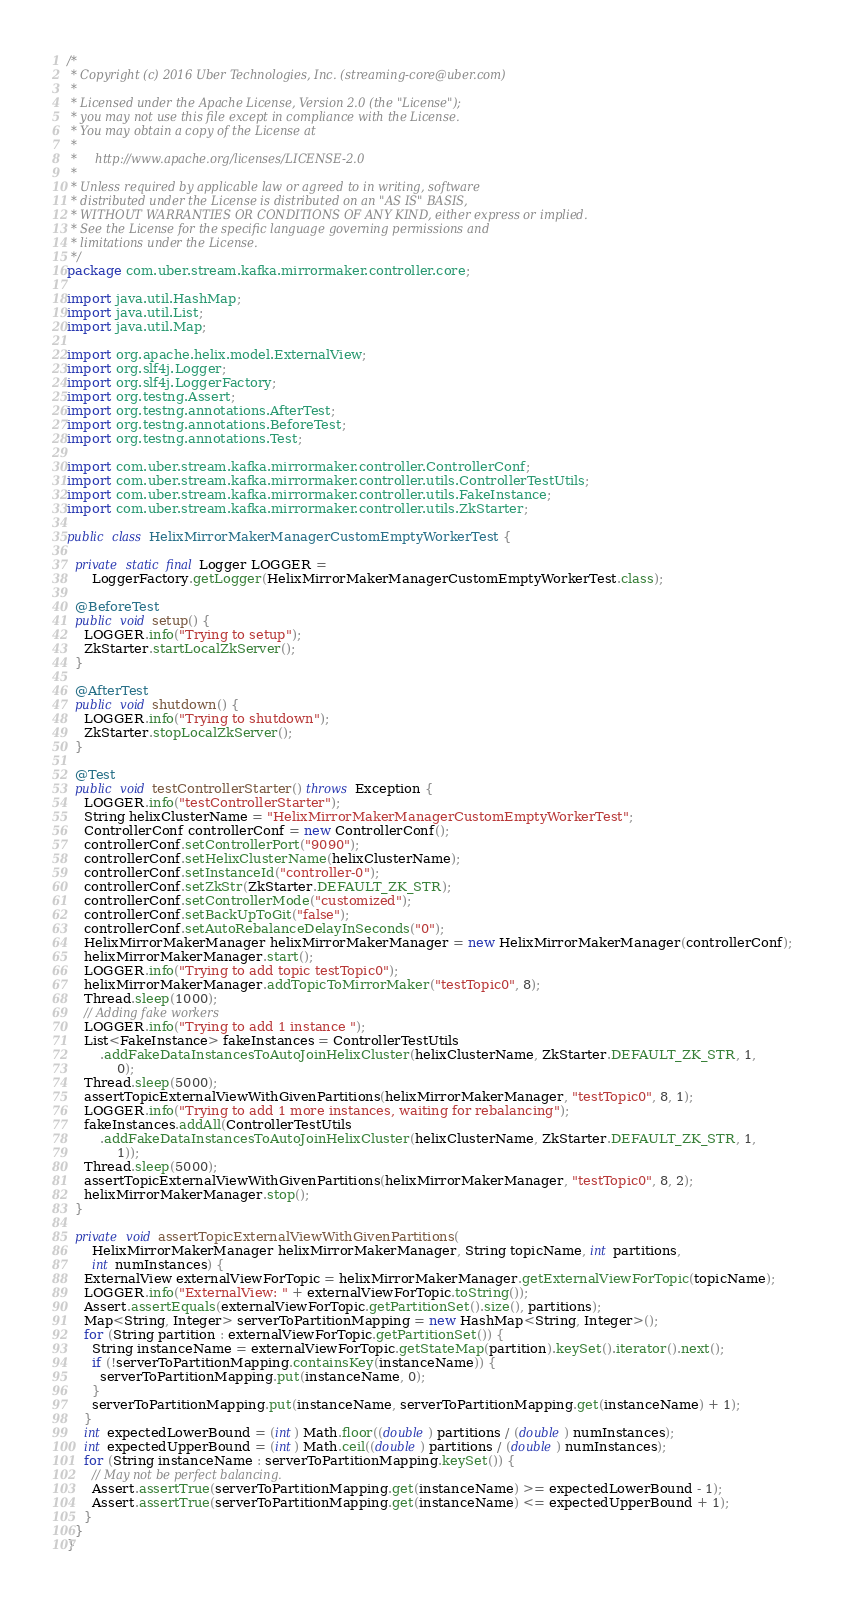Convert code to text. <code><loc_0><loc_0><loc_500><loc_500><_Java_>/*
 * Copyright (c) 2016 Uber Technologies, Inc. (streaming-core@uber.com)
 *
 * Licensed under the Apache License, Version 2.0 (the "License");
 * you may not use this file except in compliance with the License.
 * You may obtain a copy of the License at
 *
 *     http://www.apache.org/licenses/LICENSE-2.0
 *
 * Unless required by applicable law or agreed to in writing, software
 * distributed under the License is distributed on an "AS IS" BASIS,
 * WITHOUT WARRANTIES OR CONDITIONS OF ANY KIND, either express or implied.
 * See the License for the specific language governing permissions and
 * limitations under the License.
 */
package com.uber.stream.kafka.mirrormaker.controller.core;

import java.util.HashMap;
import java.util.List;
import java.util.Map;

import org.apache.helix.model.ExternalView;
import org.slf4j.Logger;
import org.slf4j.LoggerFactory;
import org.testng.Assert;
import org.testng.annotations.AfterTest;
import org.testng.annotations.BeforeTest;
import org.testng.annotations.Test;

import com.uber.stream.kafka.mirrormaker.controller.ControllerConf;
import com.uber.stream.kafka.mirrormaker.controller.utils.ControllerTestUtils;
import com.uber.stream.kafka.mirrormaker.controller.utils.FakeInstance;
import com.uber.stream.kafka.mirrormaker.controller.utils.ZkStarter;

public class HelixMirrorMakerManagerCustomEmptyWorkerTest {

  private static final Logger LOGGER =
      LoggerFactory.getLogger(HelixMirrorMakerManagerCustomEmptyWorkerTest.class);

  @BeforeTest
  public void setup() {
    LOGGER.info("Trying to setup");
    ZkStarter.startLocalZkServer();
  }

  @AfterTest
  public void shutdown() {
    LOGGER.info("Trying to shutdown");
    ZkStarter.stopLocalZkServer();
  }

  @Test
  public void testControllerStarter() throws Exception {
    LOGGER.info("testControllerStarter");
    String helixClusterName = "HelixMirrorMakerManagerCustomEmptyWorkerTest";
    ControllerConf controllerConf = new ControllerConf();
    controllerConf.setControllerPort("9090");
    controllerConf.setHelixClusterName(helixClusterName);
    controllerConf.setInstanceId("controller-0");
    controllerConf.setZkStr(ZkStarter.DEFAULT_ZK_STR);
    controllerConf.setControllerMode("customized");
    controllerConf.setBackUpToGit("false");
    controllerConf.setAutoRebalanceDelayInSeconds("0");
    HelixMirrorMakerManager helixMirrorMakerManager = new HelixMirrorMakerManager(controllerConf);
    helixMirrorMakerManager.start();
    LOGGER.info("Trying to add topic testTopic0");
    helixMirrorMakerManager.addTopicToMirrorMaker("testTopic0", 8);
    Thread.sleep(1000);
    // Adding fake workers
    LOGGER.info("Trying to add 1 instance ");
    List<FakeInstance> fakeInstances = ControllerTestUtils
        .addFakeDataInstancesToAutoJoinHelixCluster(helixClusterName, ZkStarter.DEFAULT_ZK_STR, 1,
            0);
    Thread.sleep(5000);
    assertTopicExternalViewWithGivenPartitions(helixMirrorMakerManager, "testTopic0", 8, 1);
    LOGGER.info("Trying to add 1 more instances, waiting for rebalancing");
    fakeInstances.addAll(ControllerTestUtils
        .addFakeDataInstancesToAutoJoinHelixCluster(helixClusterName, ZkStarter.DEFAULT_ZK_STR, 1,
            1));
    Thread.sleep(5000);
    assertTopicExternalViewWithGivenPartitions(helixMirrorMakerManager, "testTopic0", 8, 2);
    helixMirrorMakerManager.stop();
  }

  private void assertTopicExternalViewWithGivenPartitions(
      HelixMirrorMakerManager helixMirrorMakerManager, String topicName, int partitions,
      int numInstances) {
    ExternalView externalViewForTopic = helixMirrorMakerManager.getExternalViewForTopic(topicName);
    LOGGER.info("ExternalView: " + externalViewForTopic.toString());
    Assert.assertEquals(externalViewForTopic.getPartitionSet().size(), partitions);
    Map<String, Integer> serverToPartitionMapping = new HashMap<String, Integer>();
    for (String partition : externalViewForTopic.getPartitionSet()) {
      String instanceName = externalViewForTopic.getStateMap(partition).keySet().iterator().next();
      if (!serverToPartitionMapping.containsKey(instanceName)) {
        serverToPartitionMapping.put(instanceName, 0);
      }
      serverToPartitionMapping.put(instanceName, serverToPartitionMapping.get(instanceName) + 1);
    }
    int expectedLowerBound = (int) Math.floor((double) partitions / (double) numInstances);
    int expectedUpperBound = (int) Math.ceil((double) partitions / (double) numInstances);
    for (String instanceName : serverToPartitionMapping.keySet()) {
      // May not be perfect balancing.
      Assert.assertTrue(serverToPartitionMapping.get(instanceName) >= expectedLowerBound - 1);
      Assert.assertTrue(serverToPartitionMapping.get(instanceName) <= expectedUpperBound + 1);
    }
  }
}
</code> 